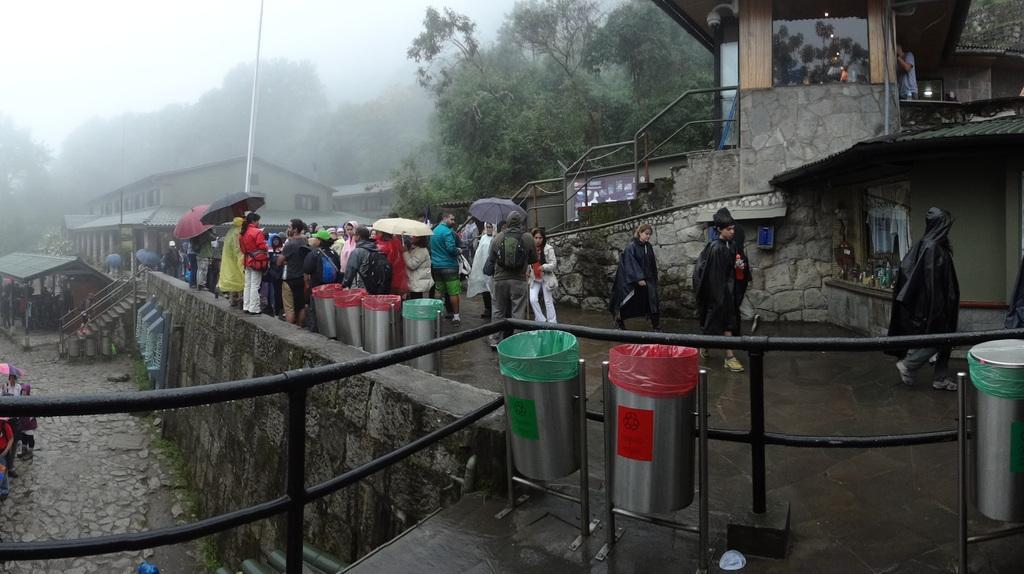How would you summarize this image in a sentence or two? This picture is clicked outside the city. In this picture, we see people are standing on the road and we even see three people are walking on the road. Most of them are holding the umbrellas in their hands. Beside them, we see the garbage bins. At the bottom, we see the railing and the road. On the right side, we see a building, staircase and stair railing. There are buildings trees and a pole in the background. It might be raining. 